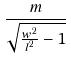Convert formula to latex. <formula><loc_0><loc_0><loc_500><loc_500>\frac { m } { \sqrt { \frac { w ^ { 2 } } { l ^ { 2 } } - 1 } }</formula> 